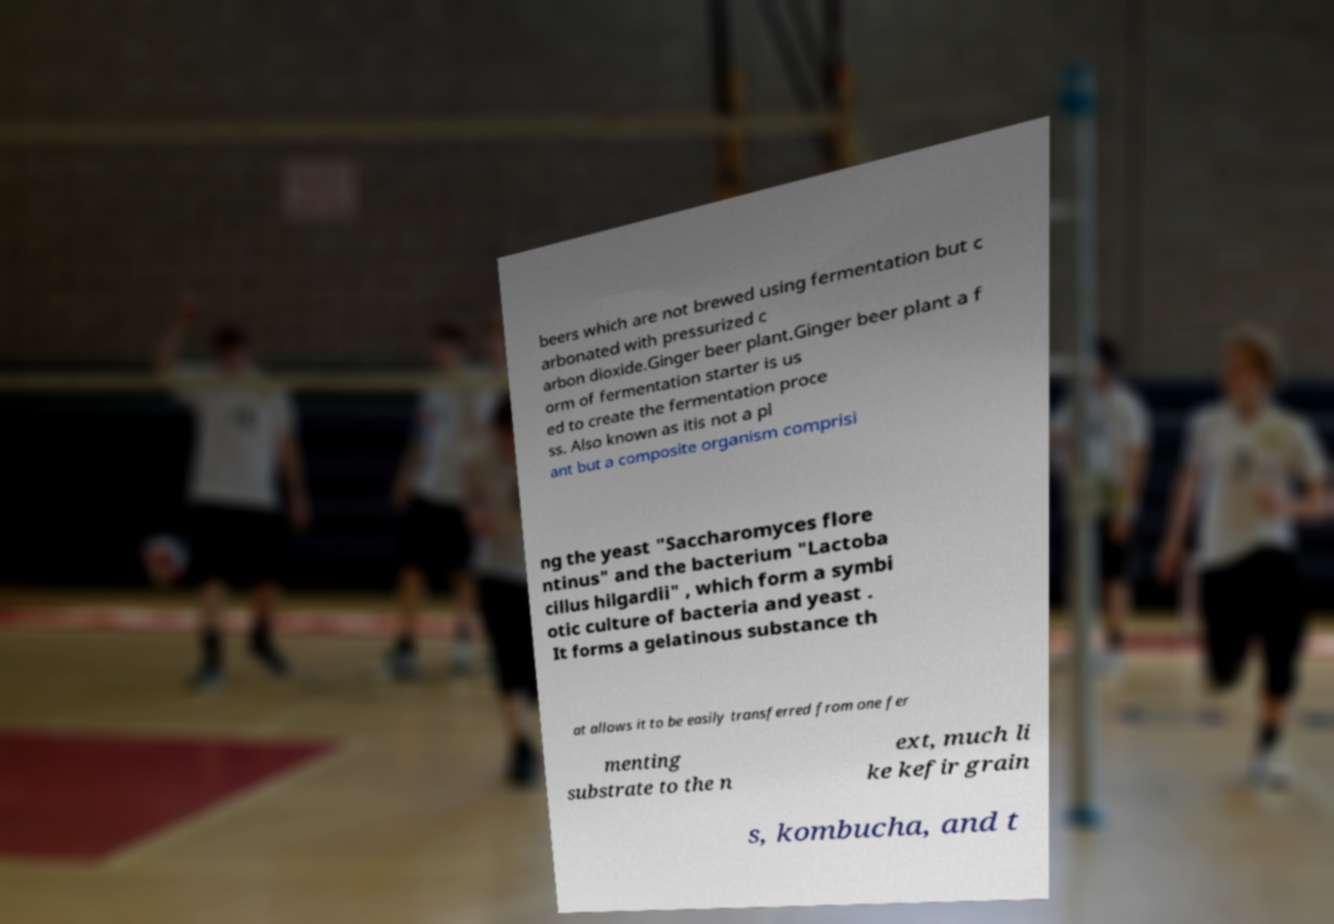Please identify and transcribe the text found in this image. beers which are not brewed using fermentation but c arbonated with pressurized c arbon dioxide.Ginger beer plant.Ginger beer plant a f orm of fermentation starter is us ed to create the fermentation proce ss. Also known as itis not a pl ant but a composite organism comprisi ng the yeast "Saccharomyces flore ntinus" and the bacterium "Lactoba cillus hilgardii" , which form a symbi otic culture of bacteria and yeast . It forms a gelatinous substance th at allows it to be easily transferred from one fer menting substrate to the n ext, much li ke kefir grain s, kombucha, and t 